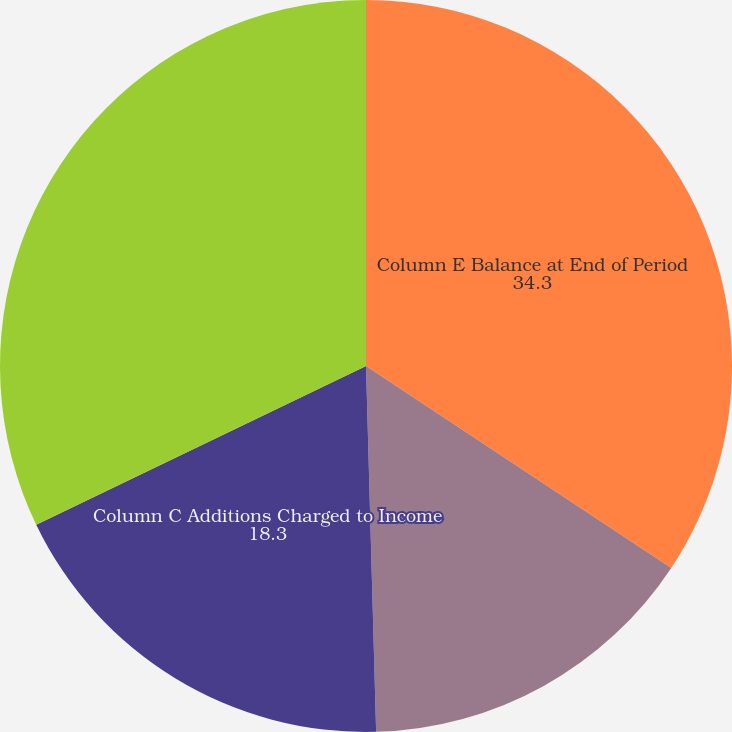Convert chart to OTSL. <chart><loc_0><loc_0><loc_500><loc_500><pie_chart><fcel>Column E Balance at End of Period<fcel>Column B Balance at Beginning  of Period<fcel>Column C Additions Charged to Income<fcel>Column D Other Changes Deductions (1)<nl><fcel>34.3%<fcel>15.26%<fcel>18.3%<fcel>32.14%<nl></chart> 